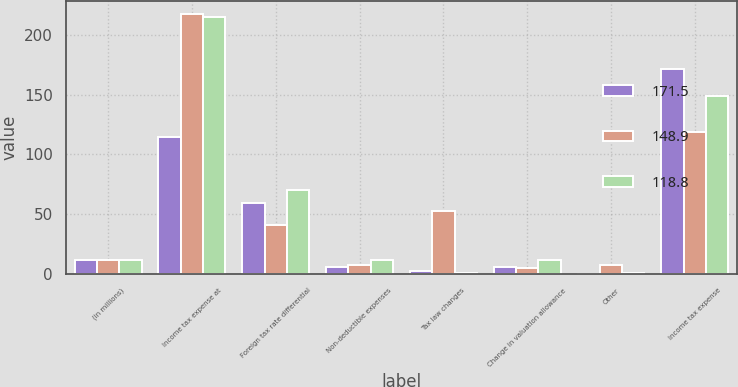<chart> <loc_0><loc_0><loc_500><loc_500><stacked_bar_chart><ecel><fcel>(in millions)<fcel>Income tax expense at<fcel>Foreign tax rate differential<fcel>Non-deductible expenses<fcel>Tax law changes<fcel>Change in valuation allowance<fcel>Other<fcel>Income tax expense<nl><fcel>171.5<fcel>12.1<fcel>114.8<fcel>59.5<fcel>5.6<fcel>2.3<fcel>5.9<fcel>0.2<fcel>171.5<nl><fcel>148.9<fcel>12.1<fcel>216.9<fcel>40.8<fcel>7.7<fcel>52.9<fcel>5.3<fcel>7.7<fcel>118.8<nl><fcel>118.8<fcel>12.1<fcel>214.7<fcel>69.9<fcel>12.1<fcel>0.7<fcel>12<fcel>0.9<fcel>148.9<nl></chart> 